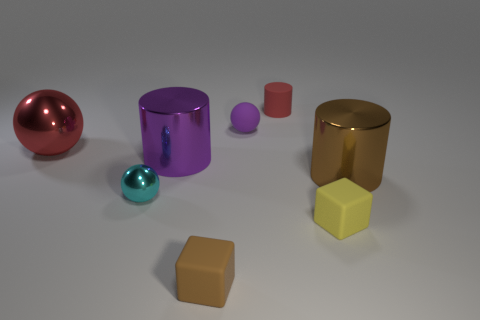Add 1 large brown objects. How many objects exist? 9 Subtract all blocks. How many objects are left? 6 Subtract 0 yellow cylinders. How many objects are left? 8 Subtract all small matte things. Subtract all tiny purple rubber spheres. How many objects are left? 3 Add 5 red cylinders. How many red cylinders are left? 6 Add 3 green shiny cubes. How many green shiny cubes exist? 3 